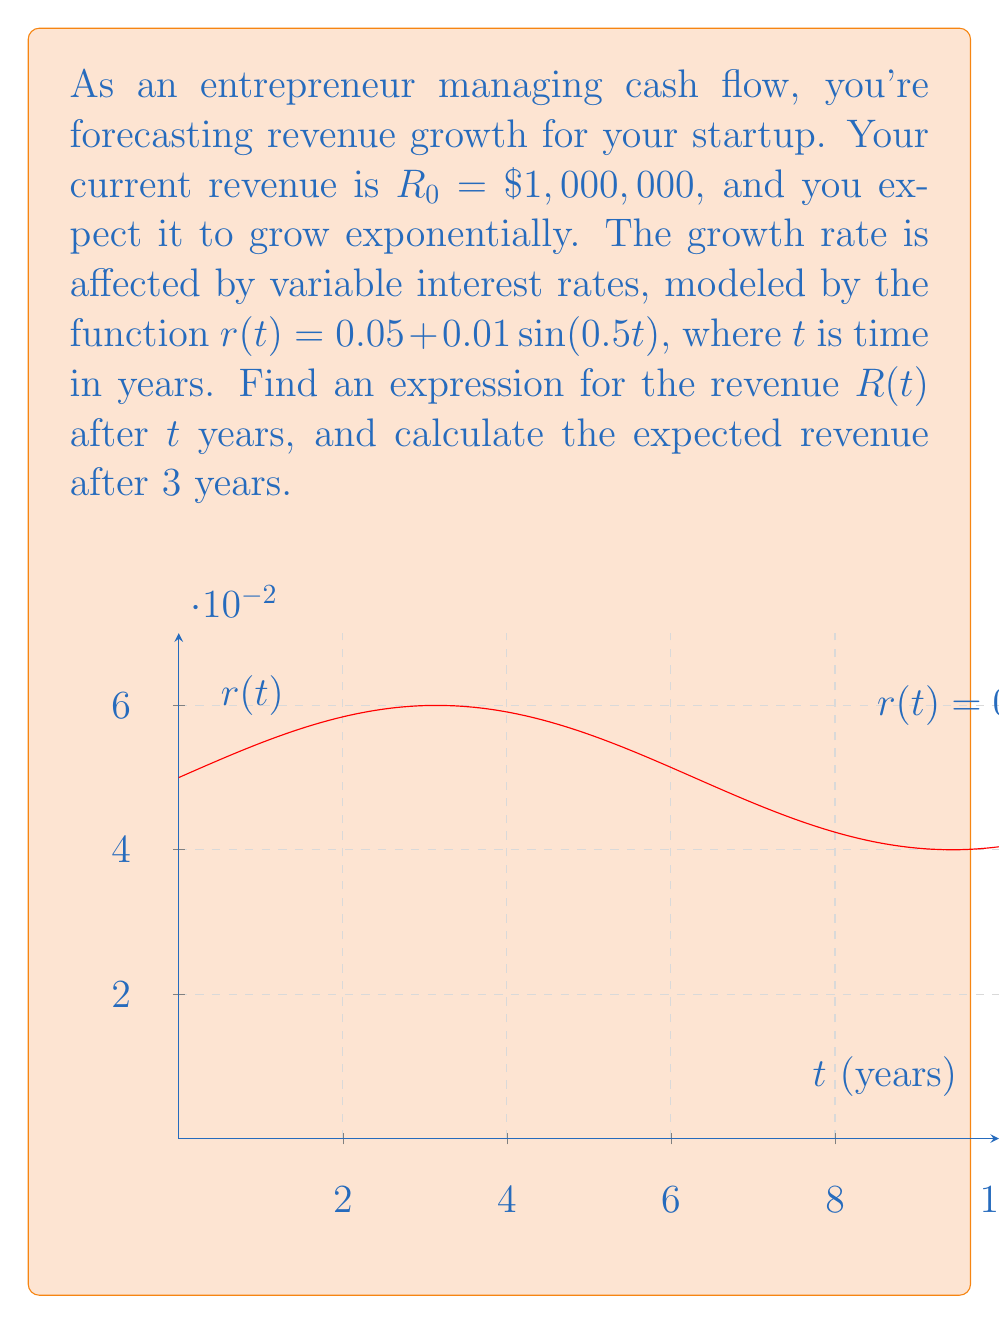Teach me how to tackle this problem. Let's approach this step-by-step:

1) The general form of the differential equation for exponential growth with a variable rate is:

   $$\frac{dR}{dt} = r(t)R$$

2) Substituting the given rate function:

   $$\frac{dR}{dt} = (0.05 + 0.01\sin(0.5t))R$$

3) To solve this, we can use the method of separation of variables:

   $$\frac{dR}{R} = (0.05 + 0.01\sin(0.5t))dt$$

4) Integrating both sides:

   $$\int\frac{dR}{R} = \int(0.05 + 0.01\sin(0.5t))dt$$

5) The left side integrates to $\ln|R|$. For the right side:

   $$\ln|R| = 0.05t - 0.02\cos(0.5t) + C$$

6) Taking the exponential of both sides:

   $$R = e^{0.05t - 0.02\cos(0.5t) + C} = Ae^{0.05t - 0.02\cos(0.5t)}$$

   where $A = e^C$ is a constant.

7) Using the initial condition $R_0 = 1,000,000$ when $t=0$:

   $$1,000,000 = Ae^{-0.02}$$
   $$A = 1,000,000e^{0.02}$$

8) Therefore, the general solution is:

   $$R(t) = 1,000,000e^{0.02}e^{0.05t - 0.02\cos(0.5t)}$$

9) To find the revenue after 3 years, substitute $t=3$:

   $$R(3) = 1,000,000e^{0.02}e^{0.05(3) - 0.02\cos(0.5(3))}$$
   $$= 1,000,000e^{0.02}e^{0.15 - 0.02\cos(1.5)}$$
   $$\approx 1,173,510.31$$
Answer: $R(t) = 1,000,000e^{0.02}e^{0.05t - 0.02\cos(0.5t)}$; $R(3) \approx \$1,173,510.31$ 